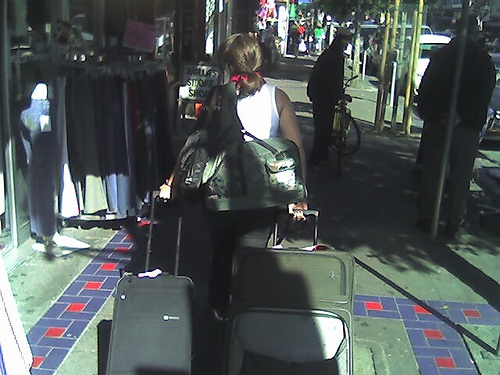Describe the objects in this image and their specific colors. I can see suitcase in black, gray, and purple tones, people in black and purple tones, suitcase in black, gray, white, and purple tones, backpack in black, gray, ivory, and darkgray tones, and people in black, gray, and darkgray tones in this image. 